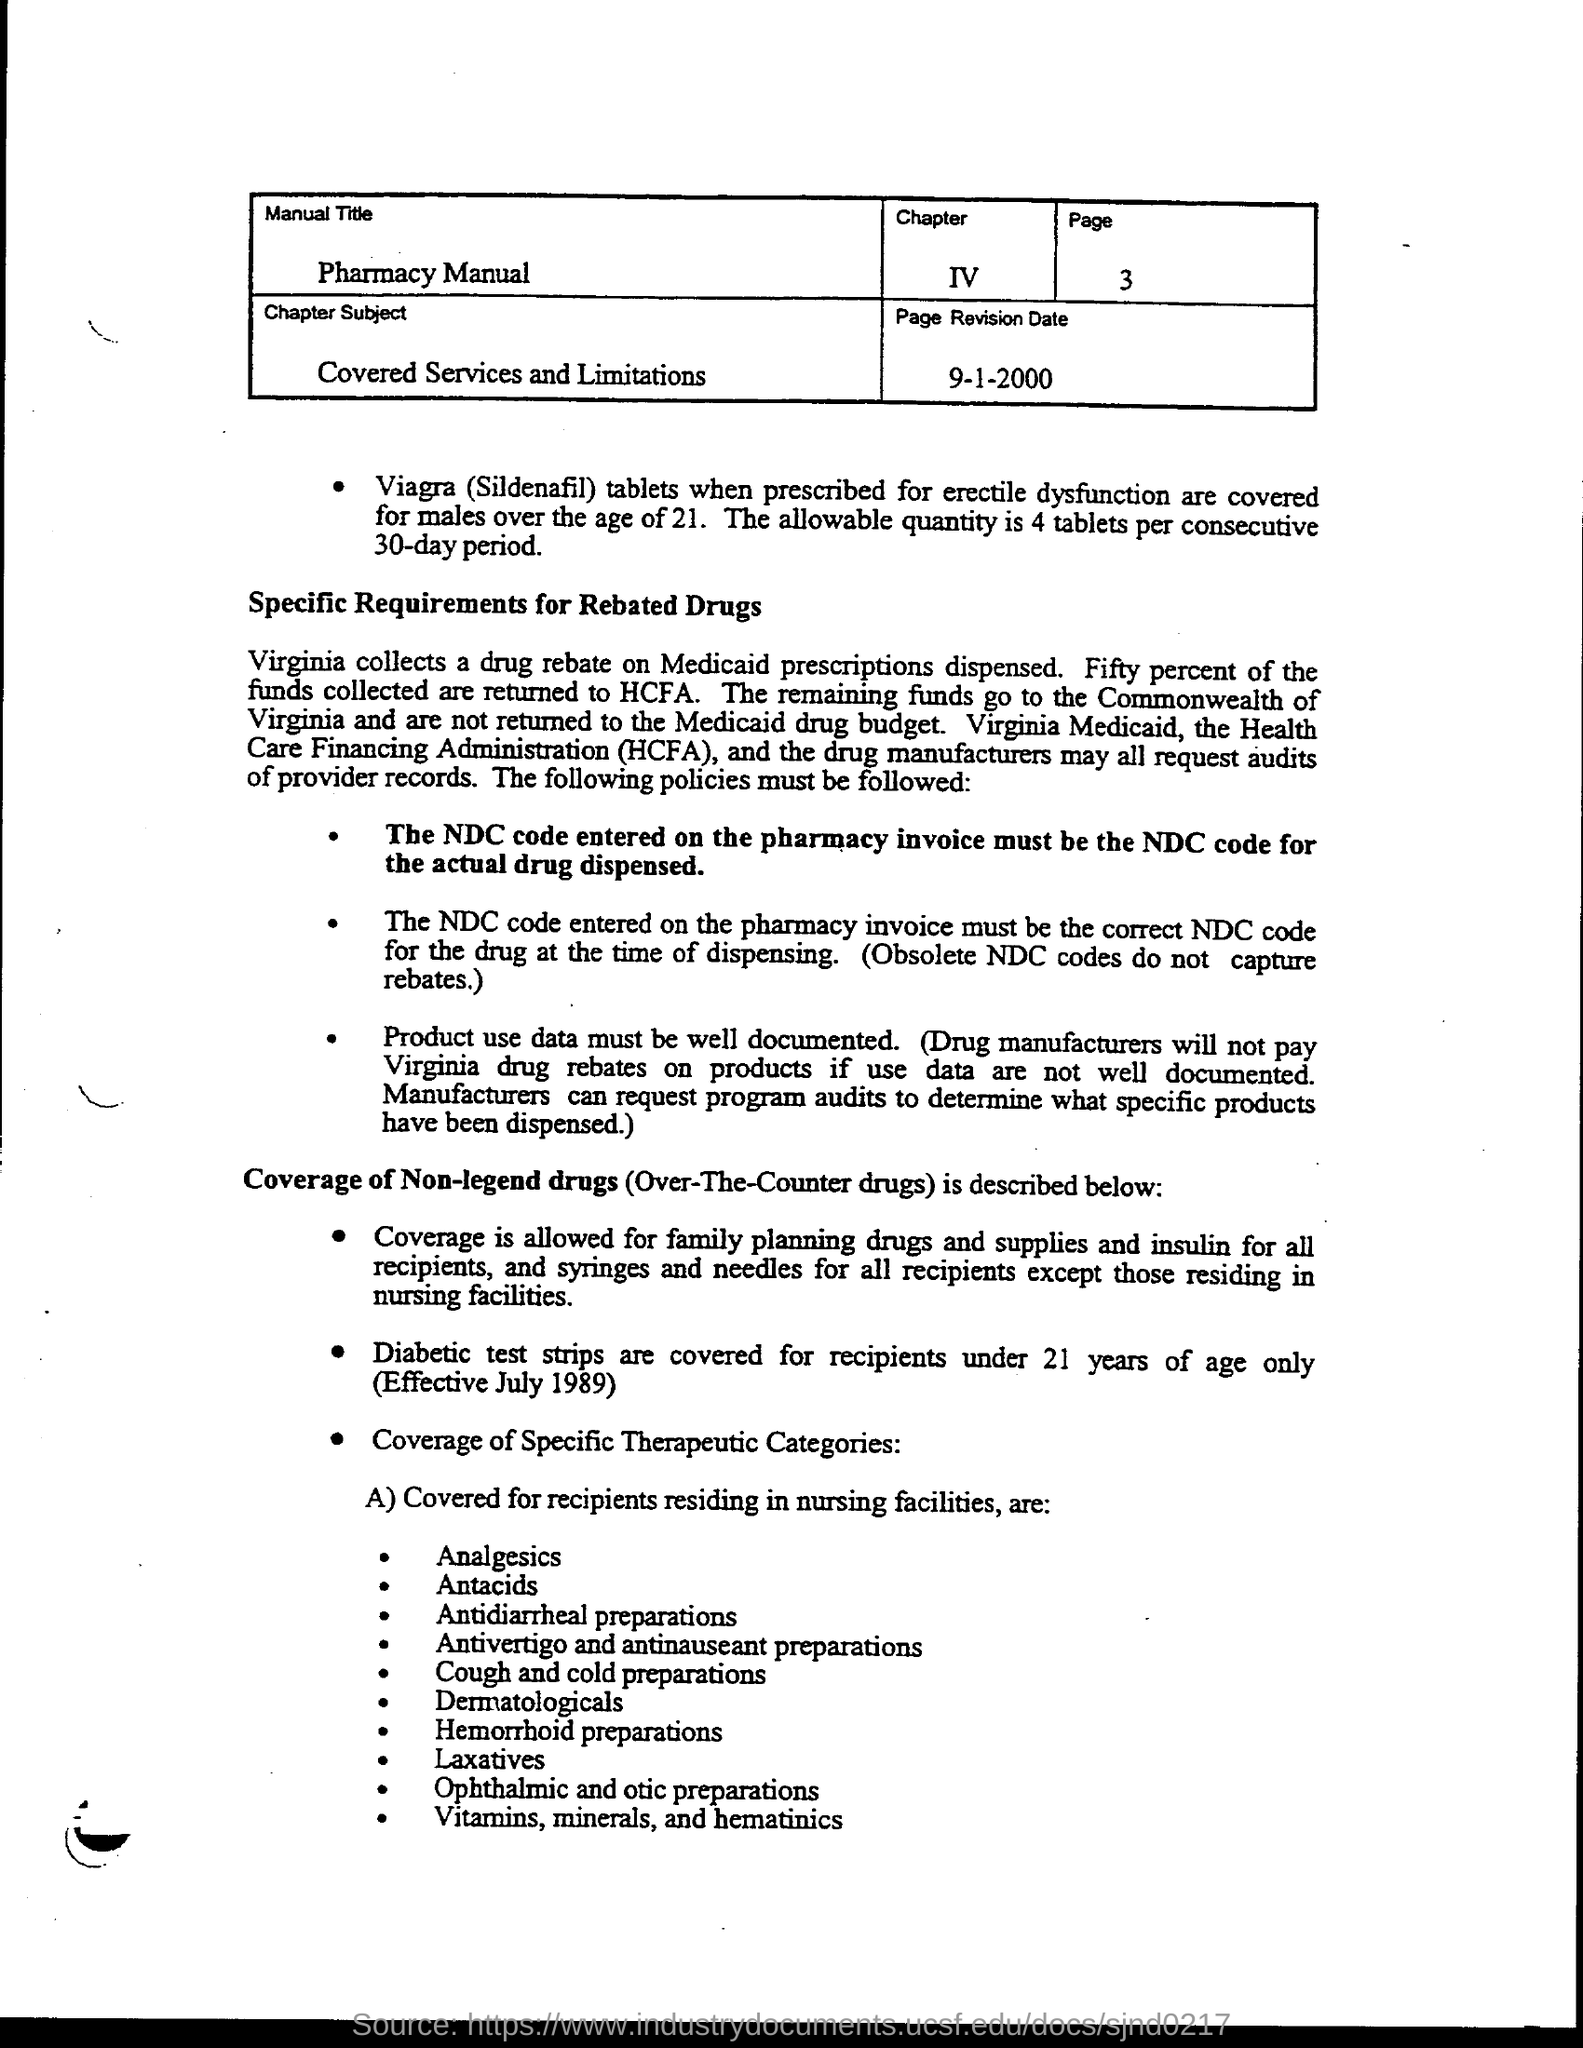What is the manual title ?
Ensure brevity in your answer.  Pharmacy manual. What is the chapter subject?
Give a very brief answer. Covered services and limitations. What is the page revision date?
Keep it short and to the point. 9-1-2000. What is the page number inside box?
Your answer should be very brief. 3. What is the chapter number ?
Offer a terse response. IV. What does hcfa stand for ?
Your answer should be very brief. Health care financing administration. 